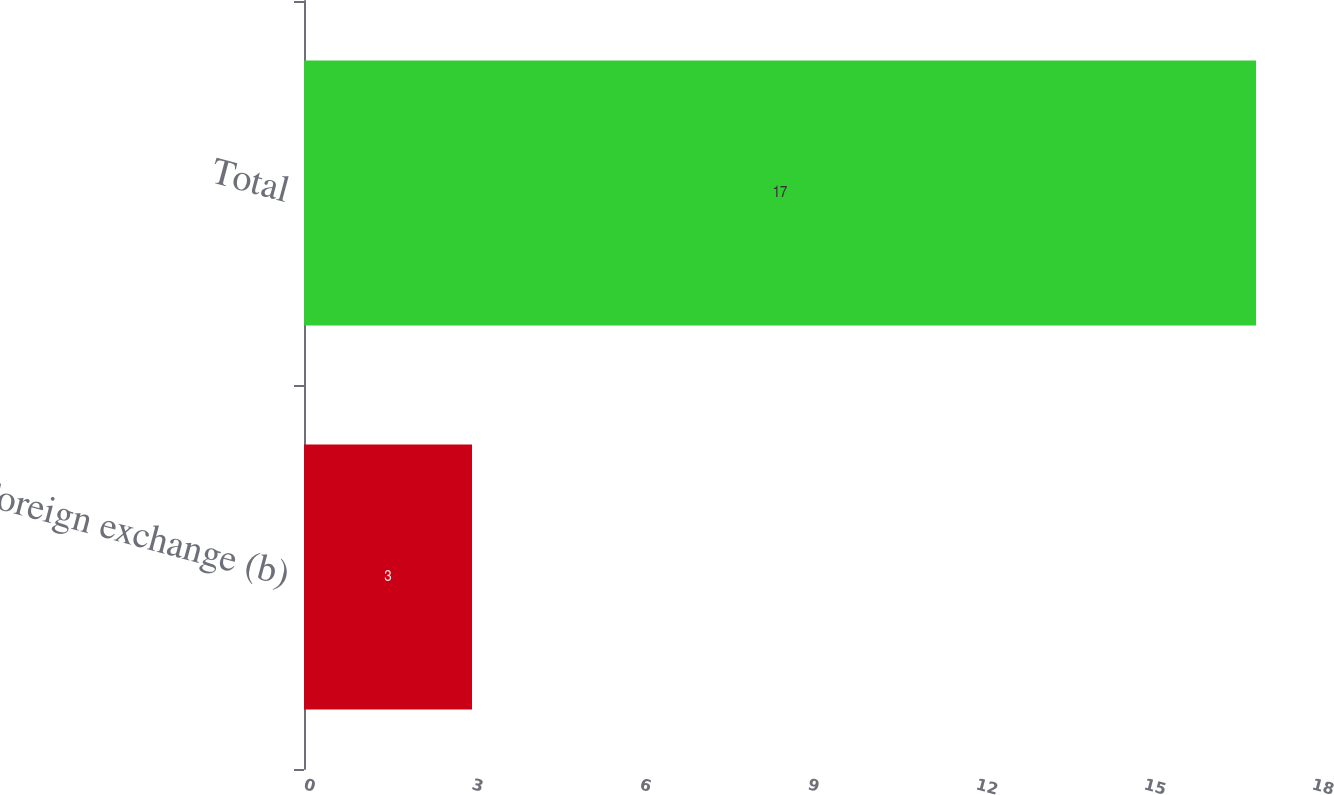<chart> <loc_0><loc_0><loc_500><loc_500><bar_chart><fcel>Foreign exchange (b)<fcel>Total<nl><fcel>3<fcel>17<nl></chart> 